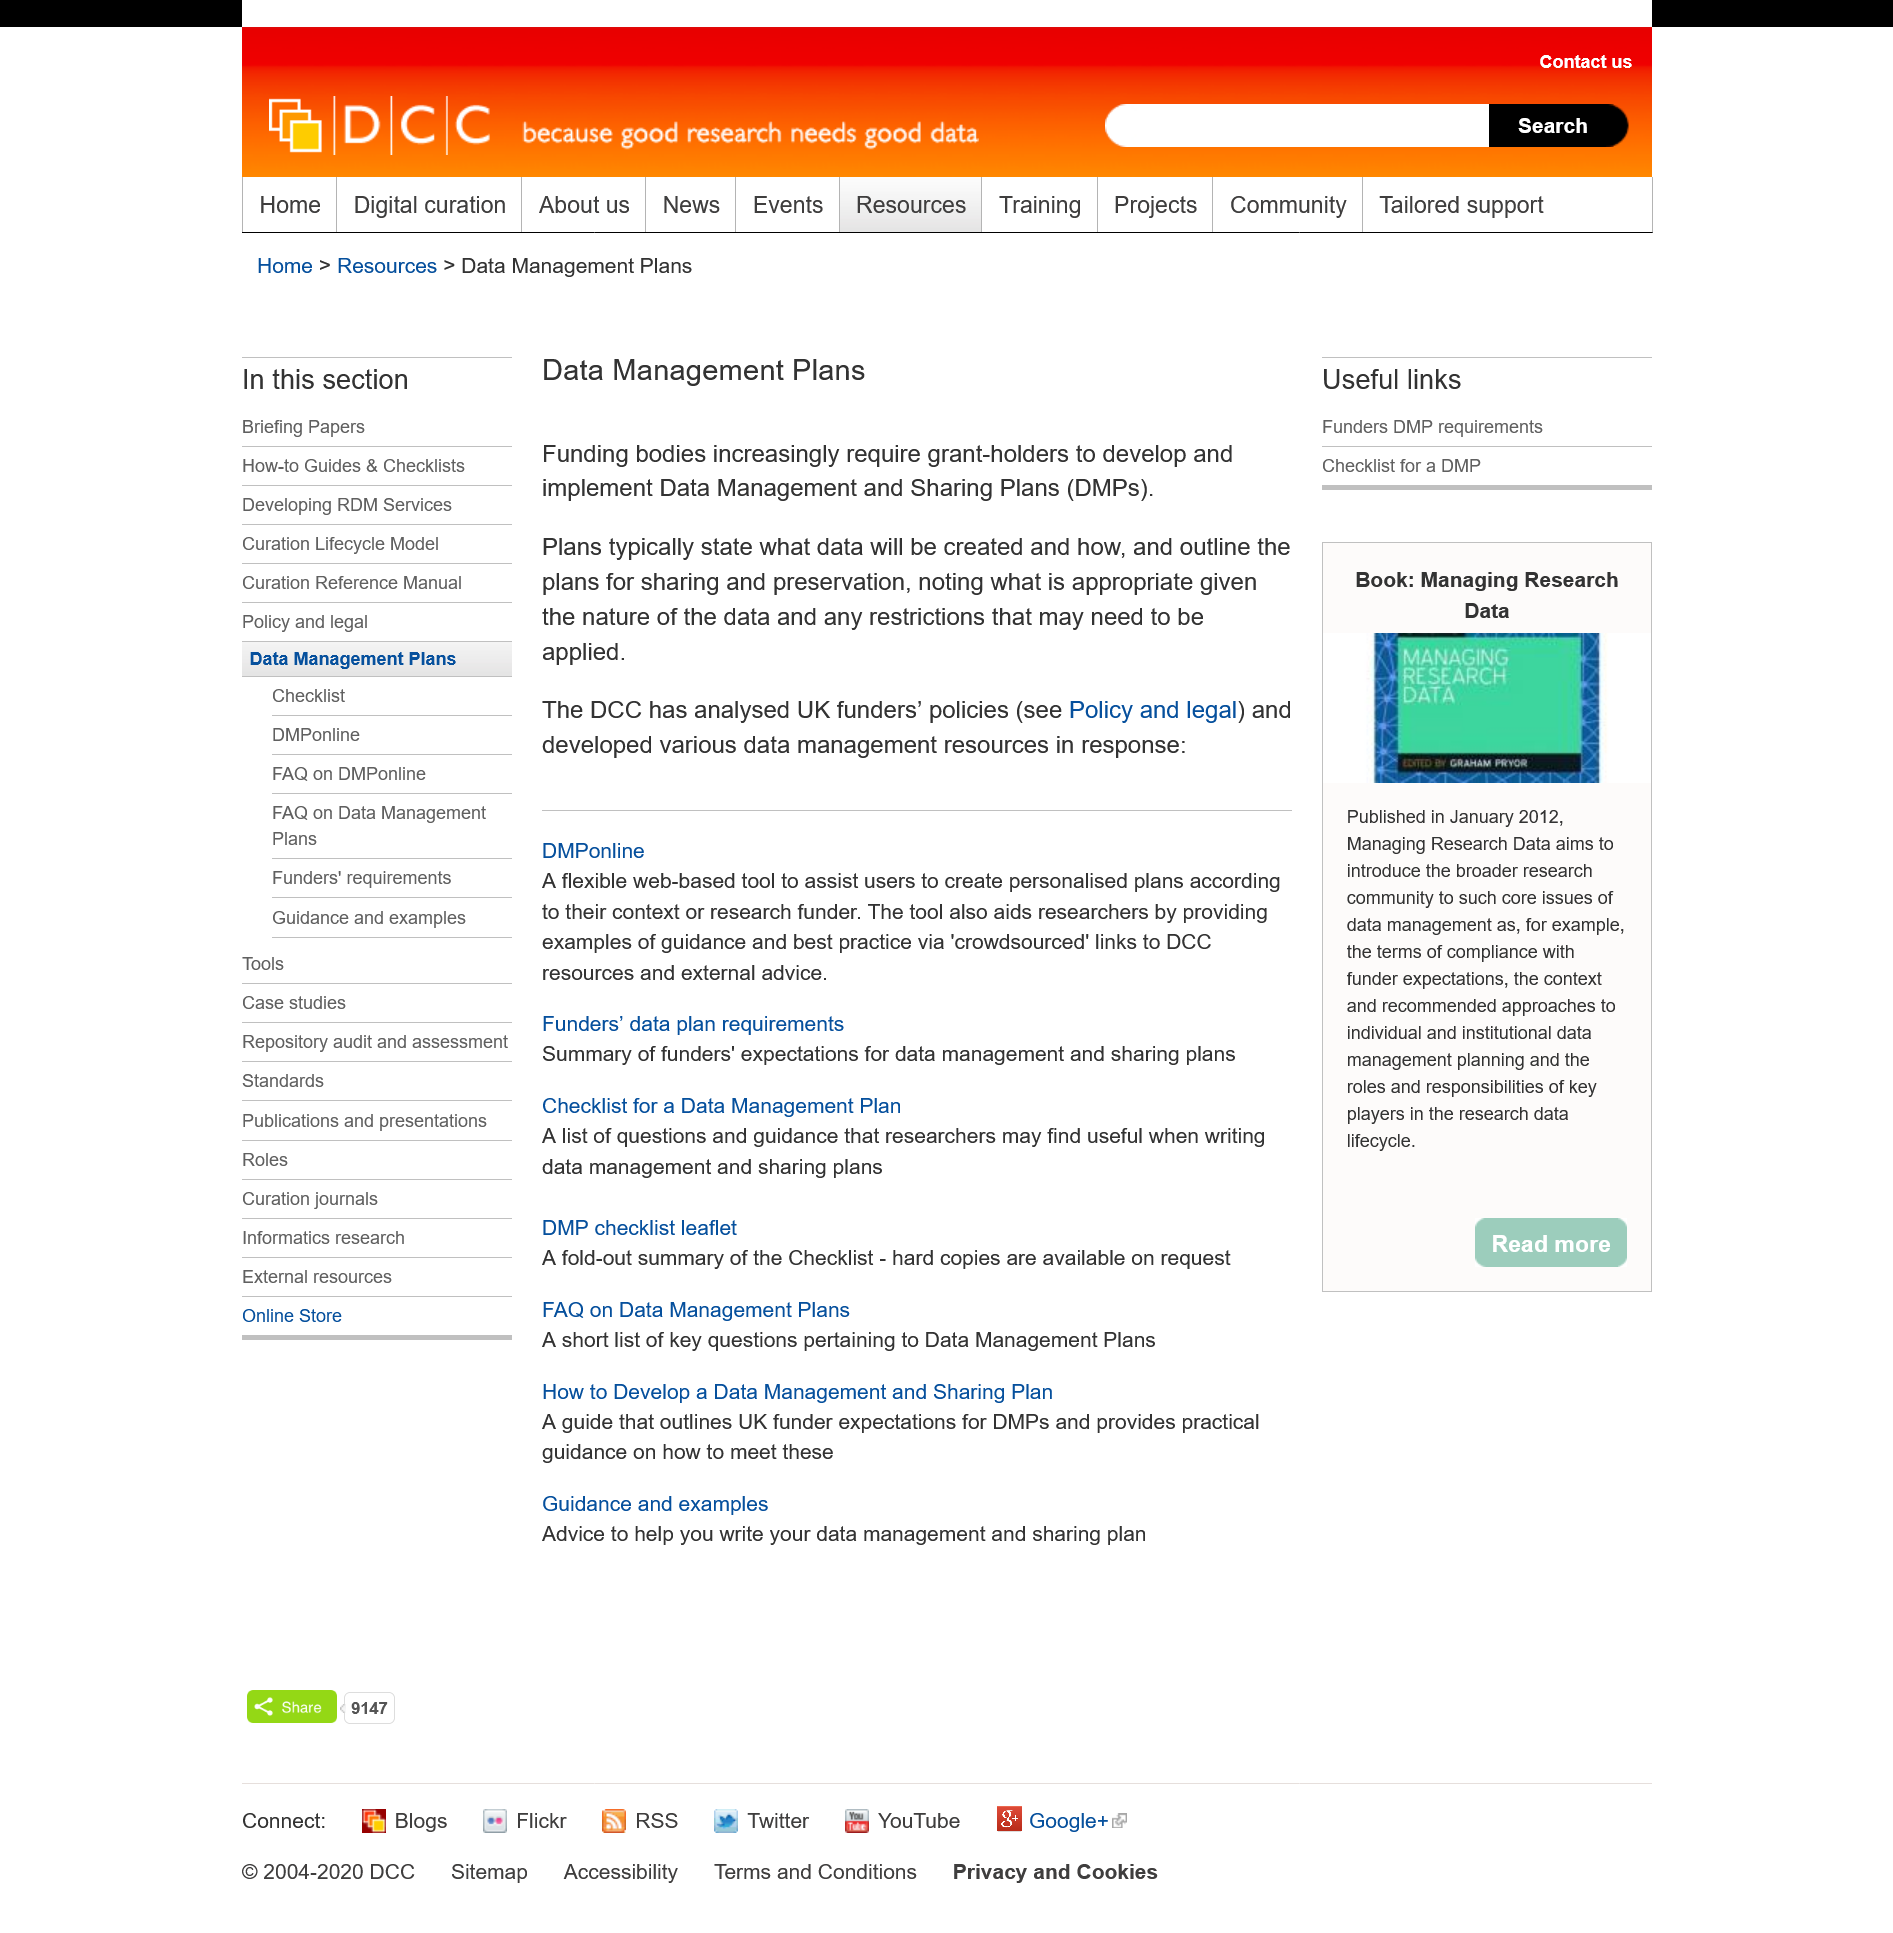Mention a couple of crucial points in this snapshot. The Digital Curation Centre (DCC) conducted an analysis of the policies of UK funders and subsequently developed various data management resources as a result. A data management plan typically outlines what data will be created and how, and it includes plans for sharing and preservation. It notes what is appropriate given the nature of the data and any restrictions that need to be applied. Funding bodies often mandate that grant applicants create and implement Data Management and Sharing Plans for their projects in order to ensure compliance with their requirements. 